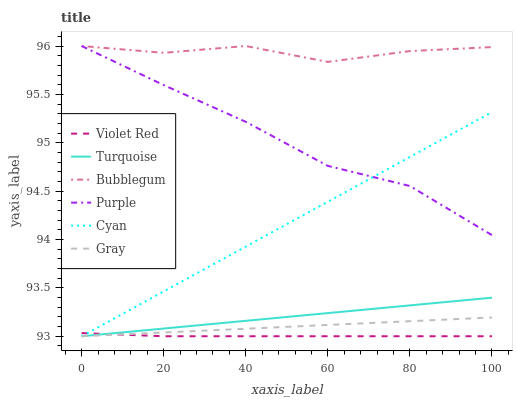Does Violet Red have the minimum area under the curve?
Answer yes or no. Yes. Does Bubblegum have the maximum area under the curve?
Answer yes or no. Yes. Does Purple have the minimum area under the curve?
Answer yes or no. No. Does Purple have the maximum area under the curve?
Answer yes or no. No. Is Turquoise the smoothest?
Answer yes or no. Yes. Is Bubblegum the roughest?
Answer yes or no. Yes. Is Violet Red the smoothest?
Answer yes or no. No. Is Violet Red the roughest?
Answer yes or no. No. Does Gray have the lowest value?
Answer yes or no. Yes. Does Purple have the lowest value?
Answer yes or no. No. Does Bubblegum have the highest value?
Answer yes or no. Yes. Does Violet Red have the highest value?
Answer yes or no. No. Is Cyan less than Bubblegum?
Answer yes or no. Yes. Is Purple greater than Turquoise?
Answer yes or no. Yes. Does Gray intersect Turquoise?
Answer yes or no. Yes. Is Gray less than Turquoise?
Answer yes or no. No. Is Gray greater than Turquoise?
Answer yes or no. No. Does Cyan intersect Bubblegum?
Answer yes or no. No. 